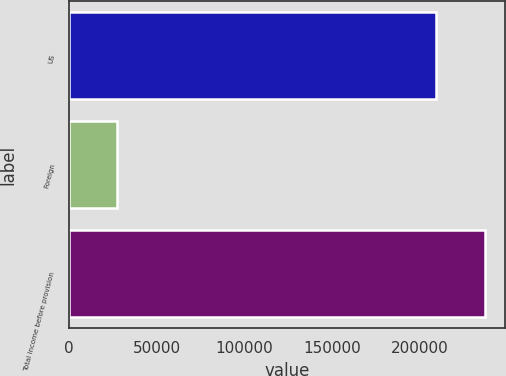Convert chart. <chart><loc_0><loc_0><loc_500><loc_500><bar_chart><fcel>US<fcel>Foreign<fcel>Total income before provision<nl><fcel>209539<fcel>27695<fcel>237234<nl></chart> 